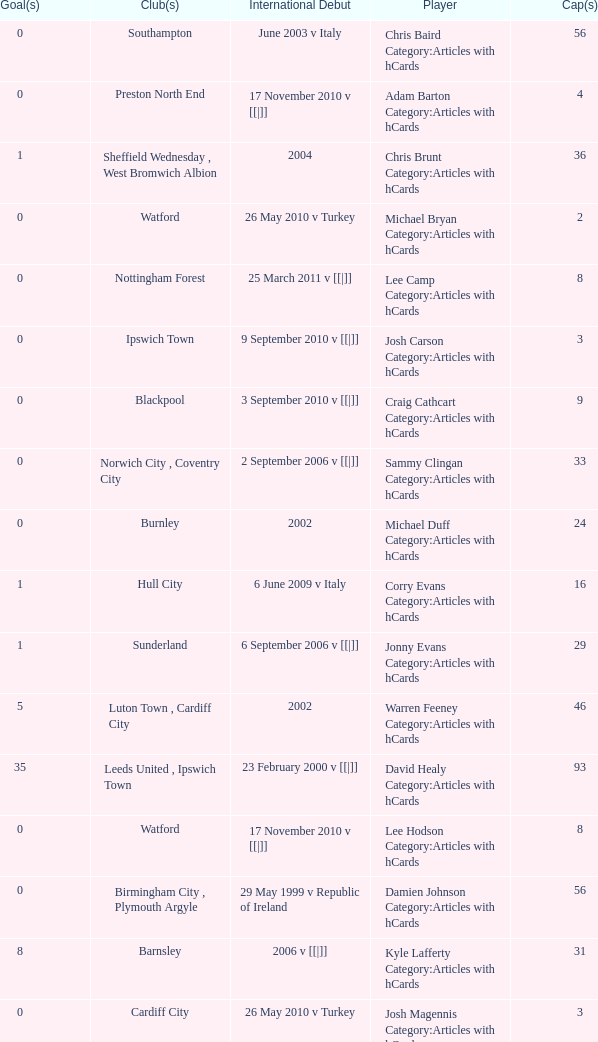How many cap statistics are there for norwich city, coventry city? 1.0. 